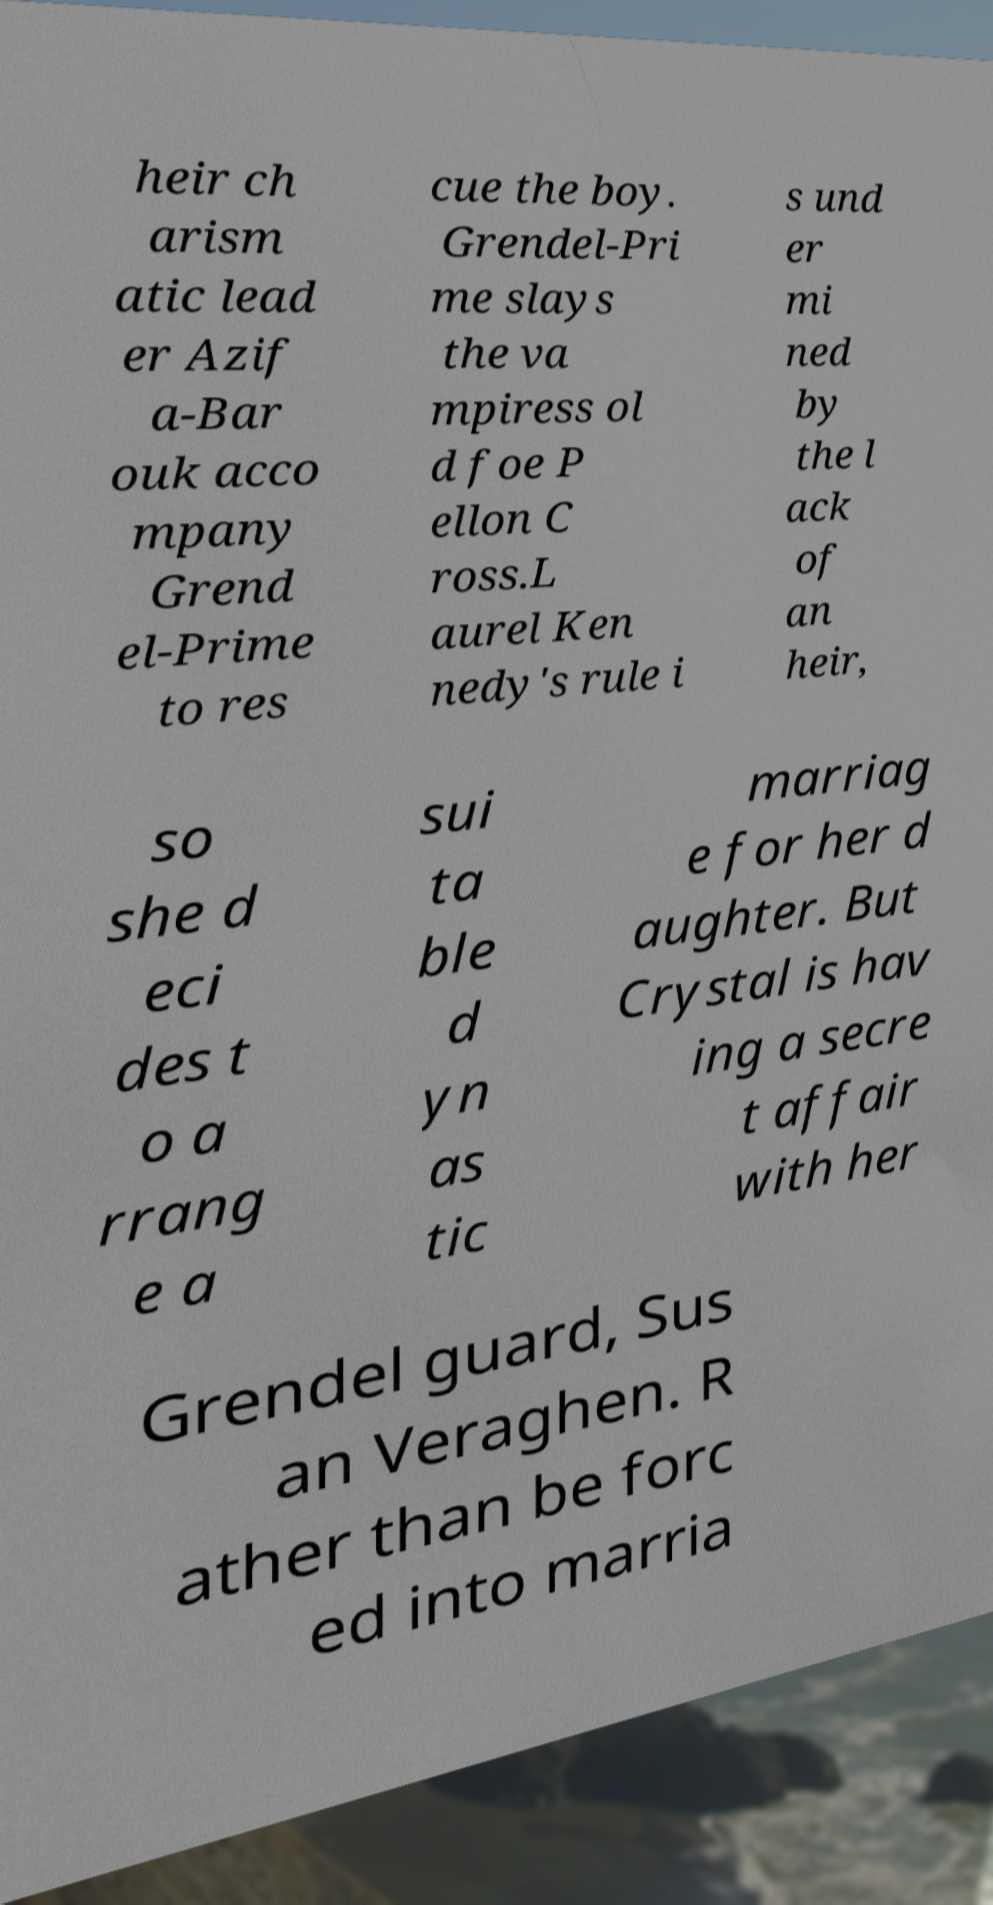Could you extract and type out the text from this image? heir ch arism atic lead er Azif a-Bar ouk acco mpany Grend el-Prime to res cue the boy. Grendel-Pri me slays the va mpiress ol d foe P ellon C ross.L aurel Ken nedy's rule i s und er mi ned by the l ack of an heir, so she d eci des t o a rrang e a sui ta ble d yn as tic marriag e for her d aughter. But Crystal is hav ing a secre t affair with her Grendel guard, Sus an Veraghen. R ather than be forc ed into marria 